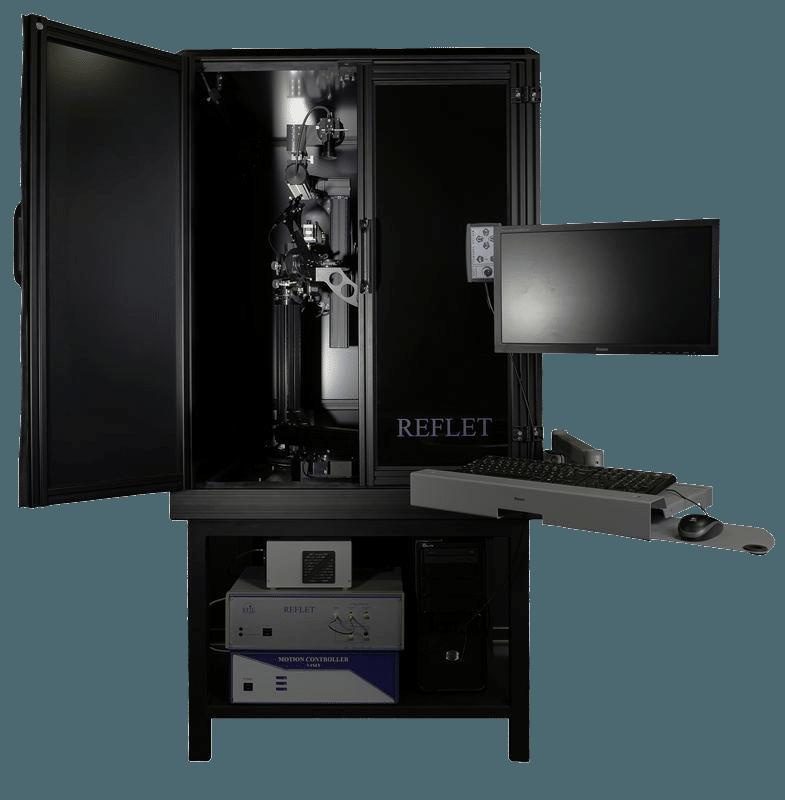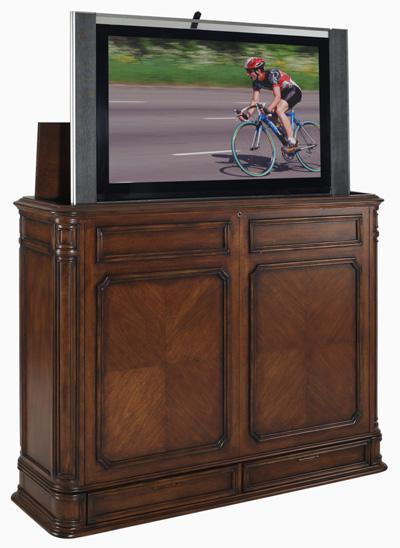The first image is the image on the left, the second image is the image on the right. Examine the images to the left and right. Is the description "At least 1 television is part of an open cabinet." accurate? Answer yes or no. Yes. 